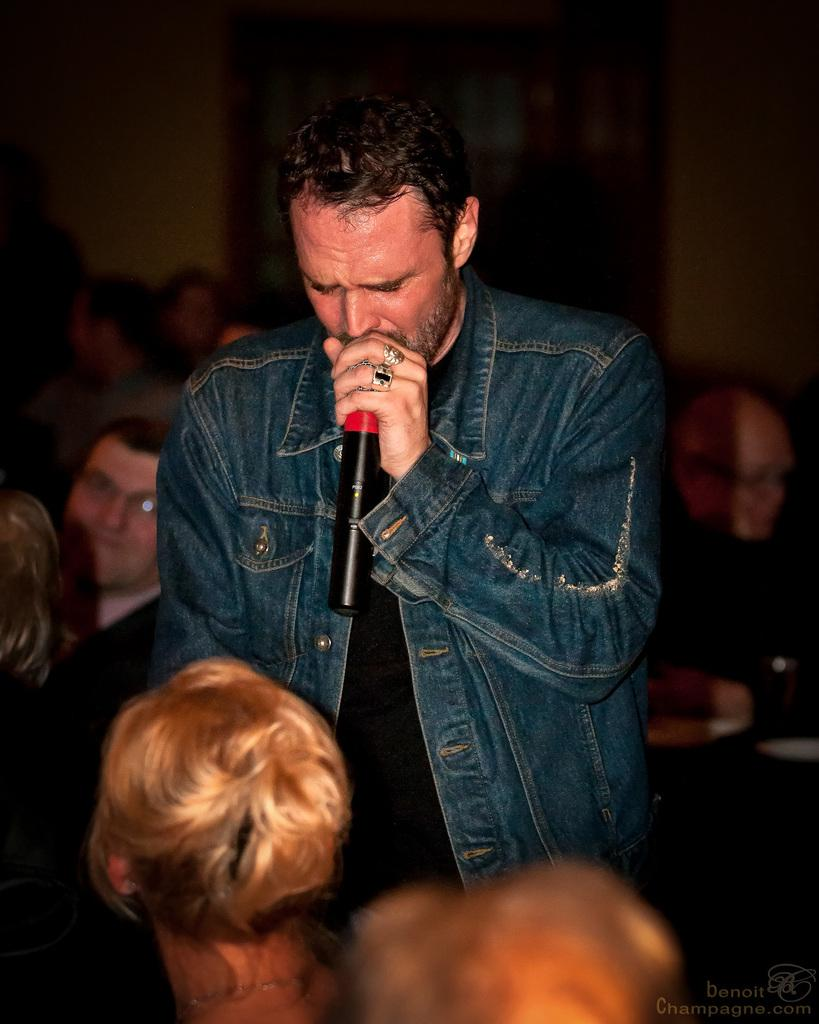What is the man in the image doing? The man is standing and holding a mic in his hand. What is the man's action while holding the mic? The man is talking. What are the people in the image doing? The people are sitting and watching the man. What can be seen in the background of the image? There is a wall in the background of the image. How much weight can the hole in the wall support? There is no hole in the wall visible in the image, so it is not possible to determine its weight-bearing capacity. 